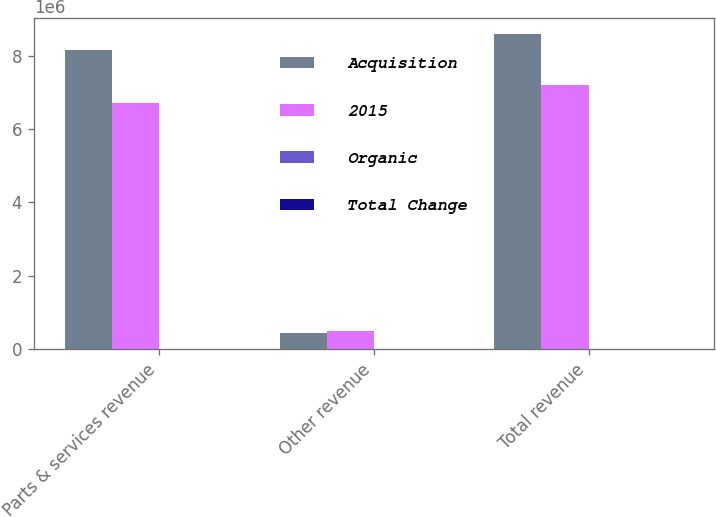Convert chart to OTSL. <chart><loc_0><loc_0><loc_500><loc_500><stacked_bar_chart><ecel><fcel>Parts & services revenue<fcel>Other revenue<fcel>Total revenue<nl><fcel>Acquisition<fcel>8.14464e+06<fcel>439386<fcel>8.58403e+06<nl><fcel>2015<fcel>6.71395e+06<fcel>478682<fcel>7.19263e+06<nl><fcel>Organic<fcel>4.8<fcel>11.2<fcel>3.7<nl><fcel>Total Change<fcel>19<fcel>3.1<fcel>18<nl></chart> 